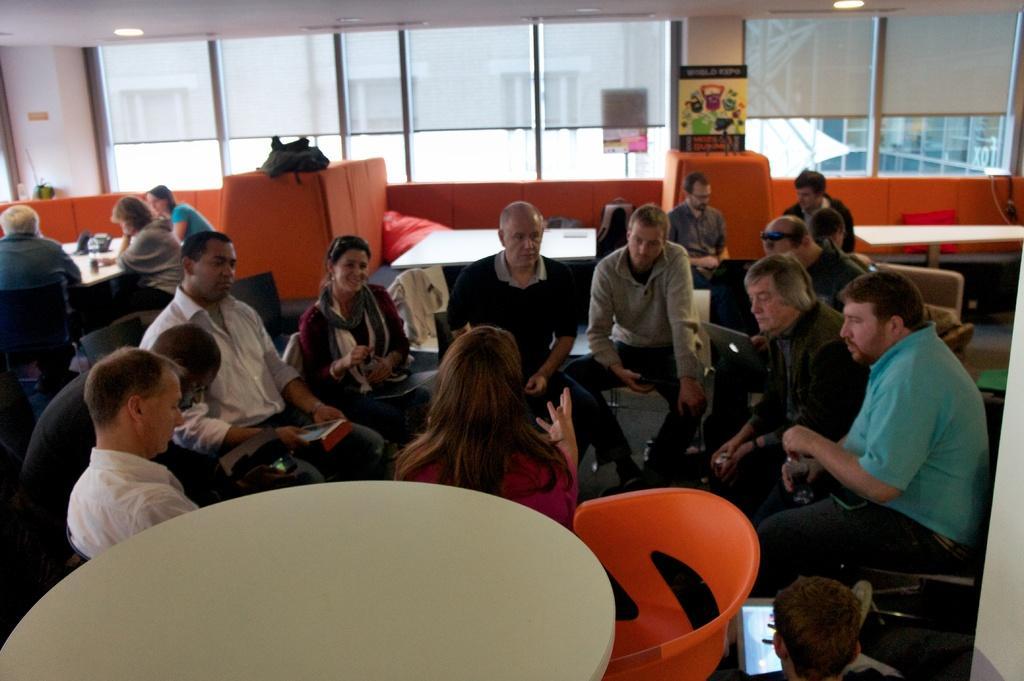Describe this image in one or two sentences. The picture is looking like it it is a group meeting. In the center of the picture there are many people seated in chairs, there are some laptops. In the background there are couches in orange color. In the foreground there is a table. On the top of the background there are windows, through the windows we can see buildings. On the top to the ceilings there are lights. 